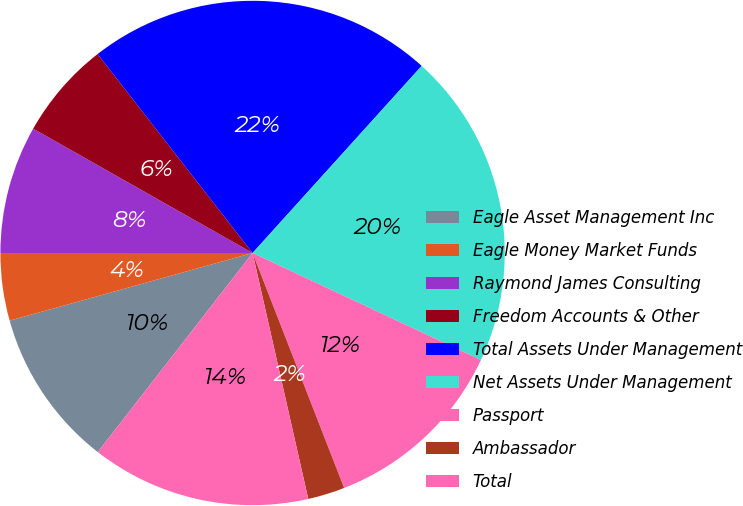Convert chart. <chart><loc_0><loc_0><loc_500><loc_500><pie_chart><fcel>Eagle Asset Management Inc<fcel>Eagle Money Market Funds<fcel>Raymond James Consulting<fcel>Freedom Accounts & Other<fcel>Total Assets Under Management<fcel>Net Assets Under Management<fcel>Passport<fcel>Ambassador<fcel>Total<nl><fcel>10.16%<fcel>4.32%<fcel>8.21%<fcel>6.26%<fcel>22.23%<fcel>20.28%<fcel>12.11%<fcel>2.37%<fcel>14.06%<nl></chart> 